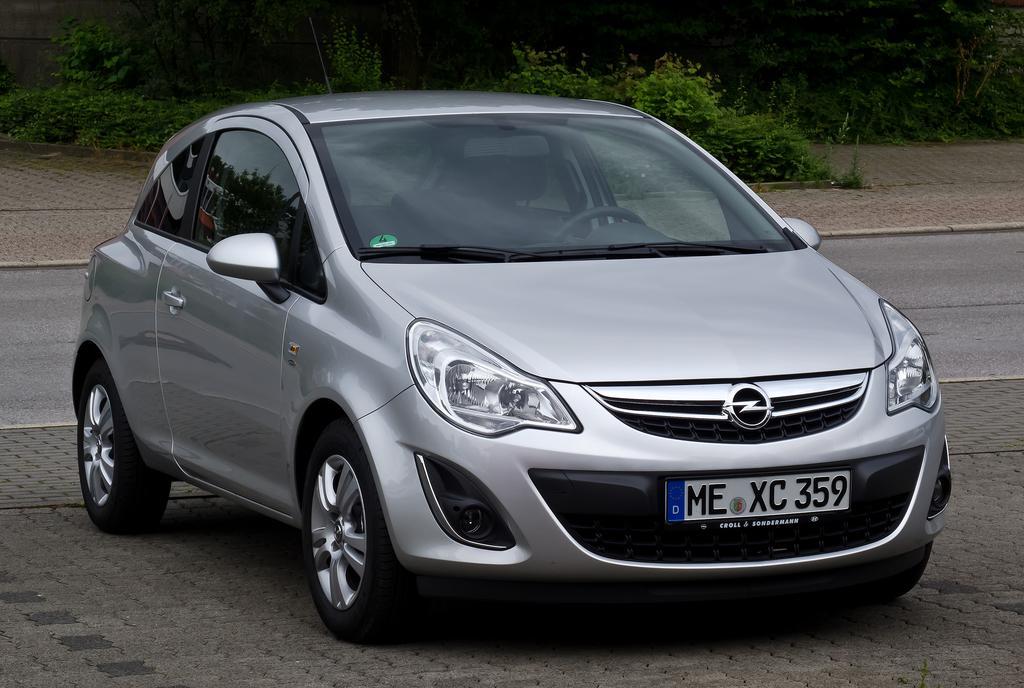Please provide a concise description of this image. It is a car which is in silver color and behind it, there is a road in the long back side there are green trees. 